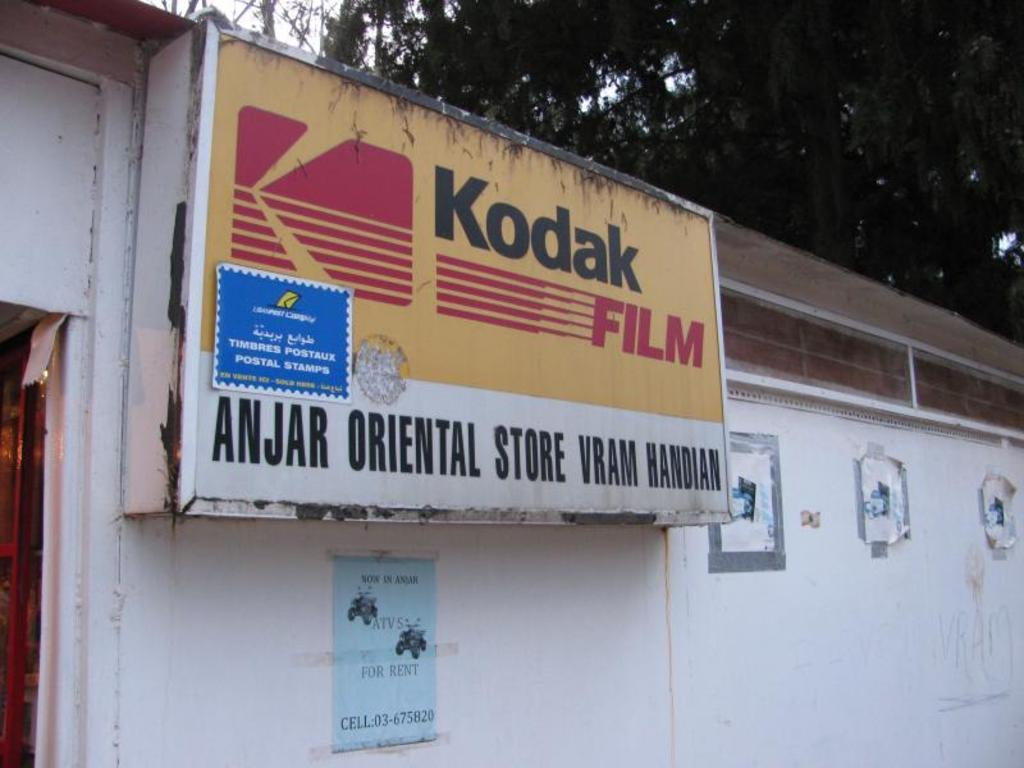What type of structure is visible in the image? There is a building in the image. How can the building be identified? The building has a name board. What is attached to the wall of the building? There are papers stuck to the wall of the building. What can be seen in the background of the image? Trees and the sky are visible in the background of the image. Where is the lamp located in the image? There is no lamp present in the image. What type of stove is used in the building in the image? There is no stove present in the image. 